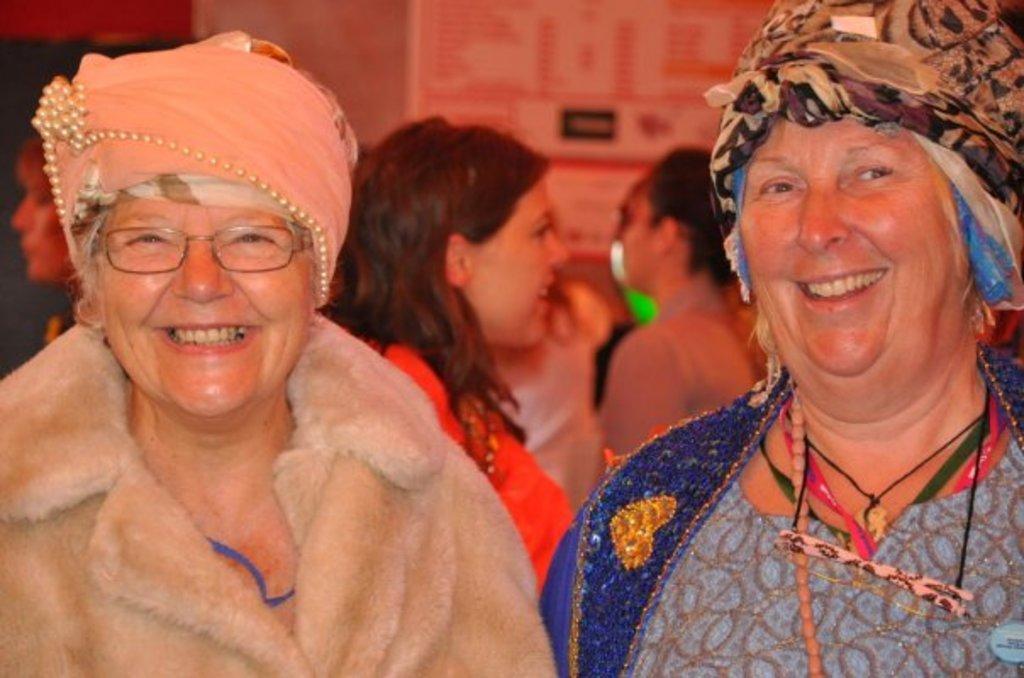In one or two sentences, can you explain what this image depicts? Here we can see two women and both are smiling. In the background we can see few persons and objects on the wall. 